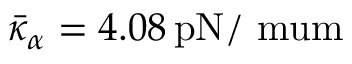Convert formula to latex. <formula><loc_0><loc_0><loc_500><loc_500>\bar { \kappa } _ { \alpha } = 4 . 0 8 \, { p N / \ m u m }</formula> 